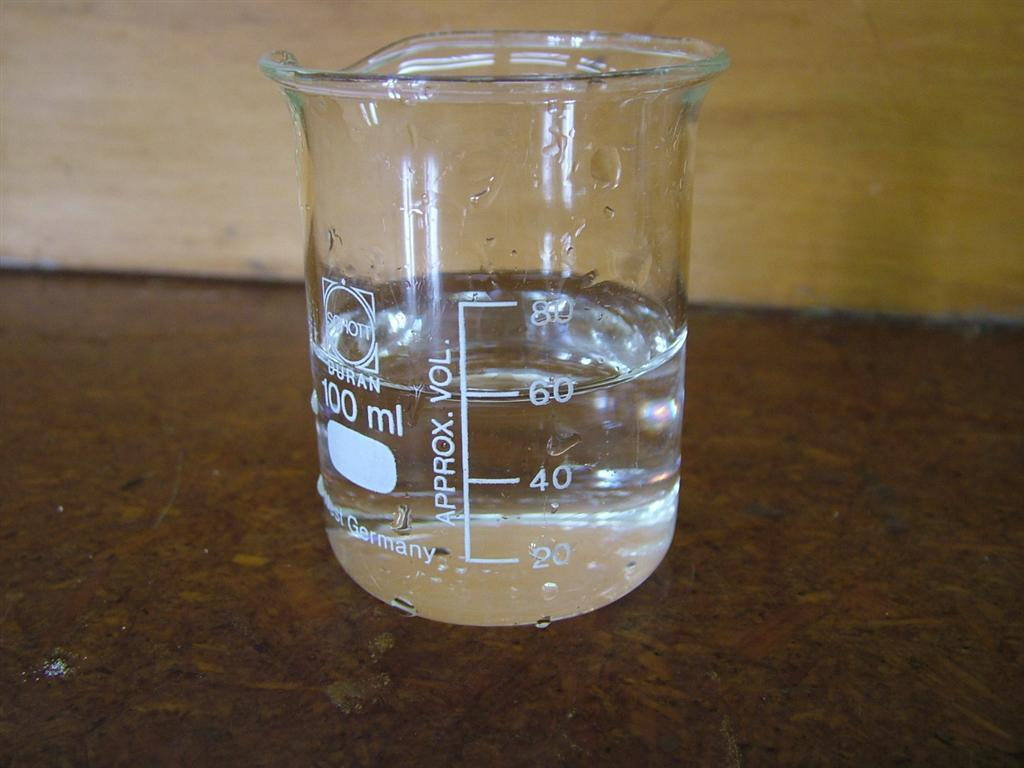<image>
Render a clear and concise summary of the photo. A beaker has the measurement 100 ml on it. 